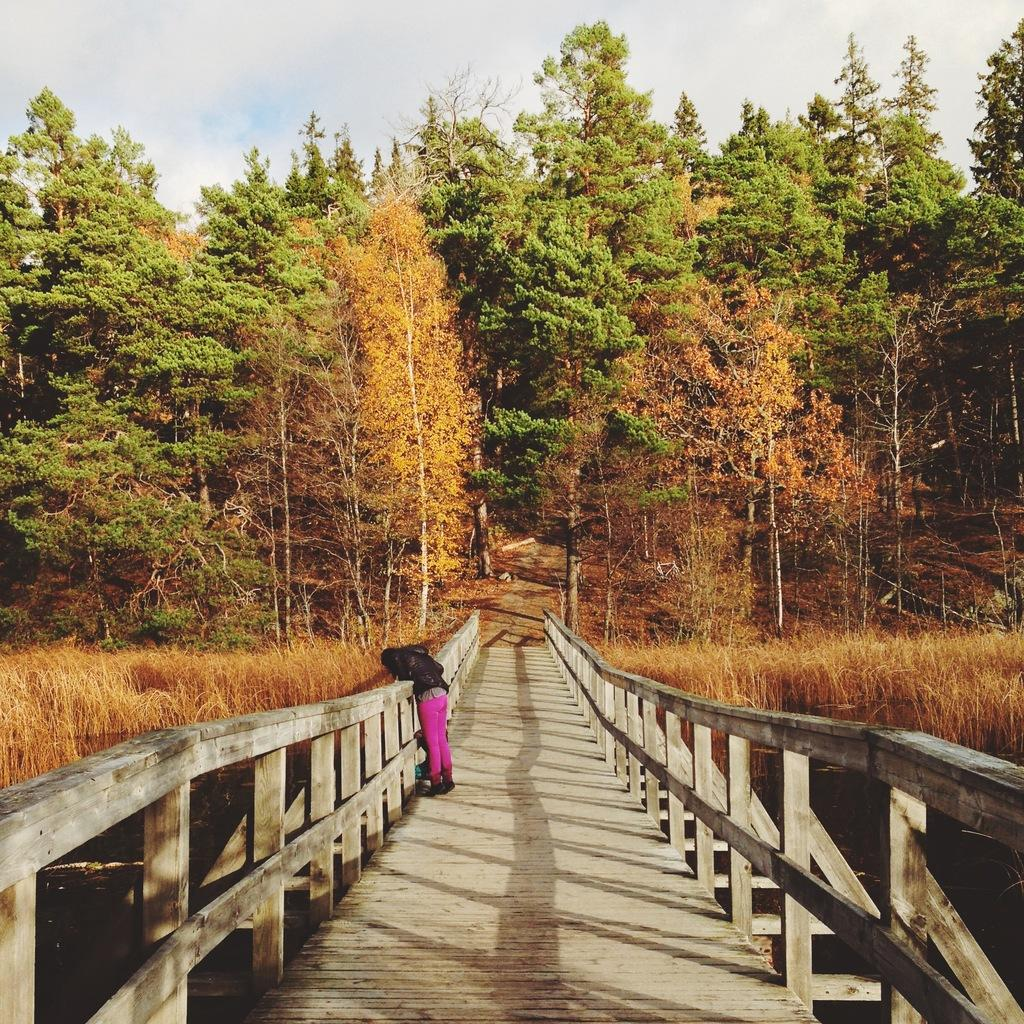What is the person in the image standing on? The person is standing on a wooden bridge. What can be seen under the bridge? There is water under the bridge. What type of vegetation is visible behind the bridge? There is grass and trees behind the bridge. What is visible in the background of the image? The sky is visible behind the bridge. What type of zinc advertisement can be seen on the bridge in the image? There is no zinc advertisement present in the image; it features a person standing on a wooden bridge with water, grass, trees, and the sky visible in the background. 